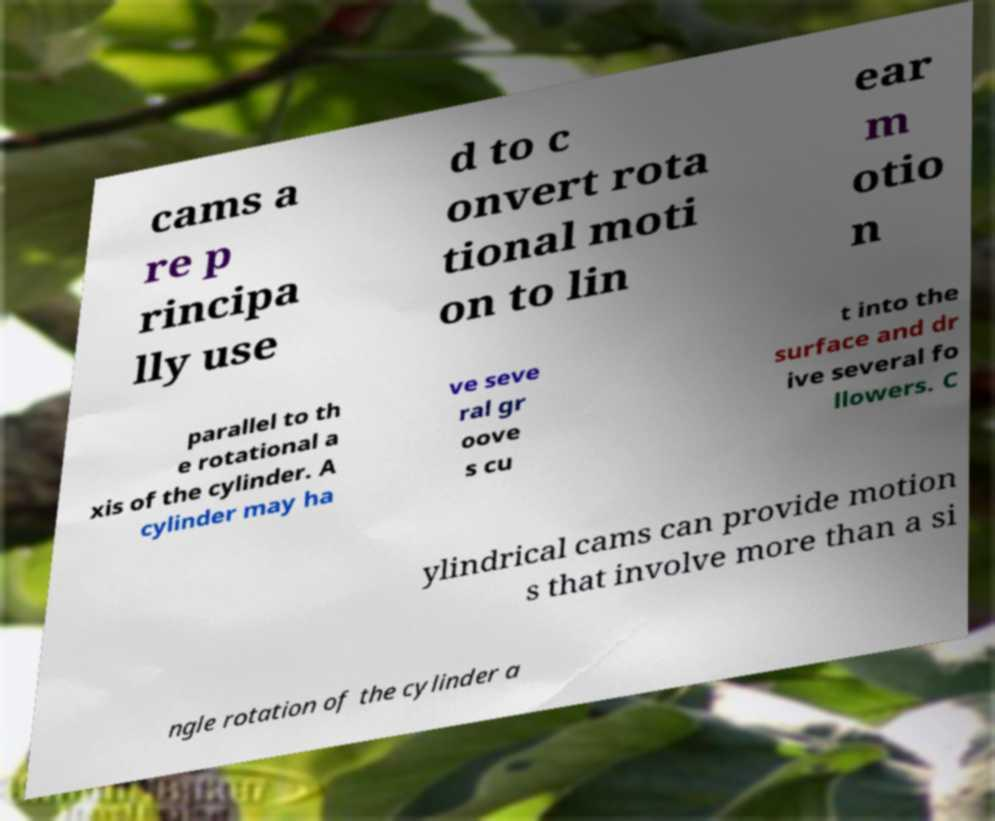I need the written content from this picture converted into text. Can you do that? cams a re p rincipa lly use d to c onvert rota tional moti on to lin ear m otio n parallel to th e rotational a xis of the cylinder. A cylinder may ha ve seve ral gr oove s cu t into the surface and dr ive several fo llowers. C ylindrical cams can provide motion s that involve more than a si ngle rotation of the cylinder a 